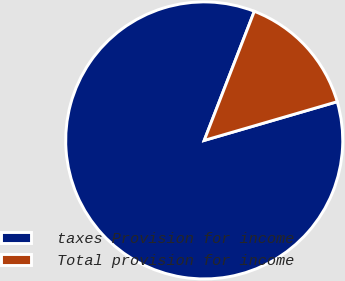<chart> <loc_0><loc_0><loc_500><loc_500><pie_chart><fcel>taxes Provision for income<fcel>Total provision for income<nl><fcel>85.4%<fcel>14.6%<nl></chart> 